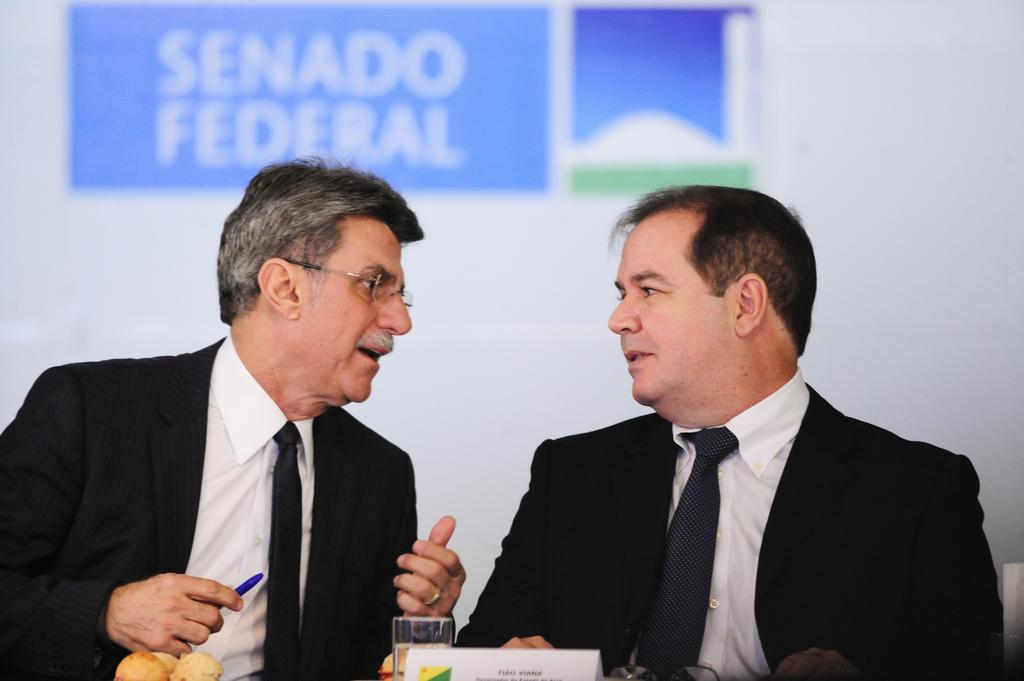How many people are in the image? There are two men in the image. What is placed in front of the men? There is a glass and a name board in front of the men. Are there any other objects in front of the men? Yes, there are other things in front of the men. What can be seen on the wall in the background of the image? There is a poster on the wall in the background of the image. What type of design can be seen on the tongue of the man on the left? There is no indication of a tongue or any design on it in the image. 